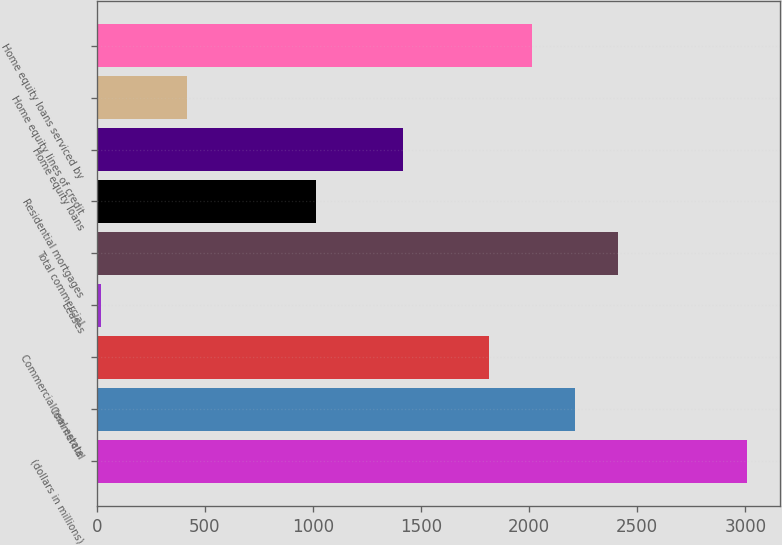Convert chart to OTSL. <chart><loc_0><loc_0><loc_500><loc_500><bar_chart><fcel>(dollars in millions)<fcel>Commercial<fcel>Commercial real estate<fcel>Leases<fcel>Total commercial<fcel>Residential mortgages<fcel>Home equity loans<fcel>Home equity lines of credit<fcel>Home equity loans serviced by<nl><fcel>3010<fcel>2212.4<fcel>1813.6<fcel>19<fcel>2411.8<fcel>1016<fcel>1414.8<fcel>417.8<fcel>2013<nl></chart> 